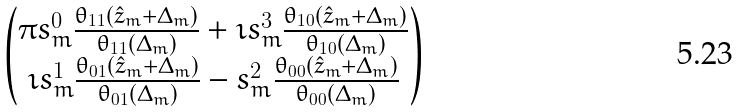Convert formula to latex. <formula><loc_0><loc_0><loc_500><loc_500>\begin{pmatrix} \pi s _ { m } ^ { 0 } \frac { \theta _ { 1 1 } ( \hat { z } _ { m } + \Delta _ { m } ) } { \theta _ { 1 1 } ( \Delta _ { m } ) } + \imath s _ { m } ^ { 3 } \frac { \theta _ { 1 0 } ( \hat { z } _ { m } + \Delta _ { m } ) } { \theta _ { 1 0 } ( \Delta _ { m } ) } \\ \imath s _ { m } ^ { 1 } \frac { \theta _ { 0 1 } ( \hat { z } _ { m } + \Delta _ { m } ) } { \theta _ { 0 1 } ( \Delta _ { m } ) } - s _ { m } ^ { 2 } \frac { \theta _ { 0 0 } ( \hat { z } _ { m } + \Delta _ { m } ) } { \theta _ { 0 0 } ( \Delta _ { m } ) } \end{pmatrix}</formula> 